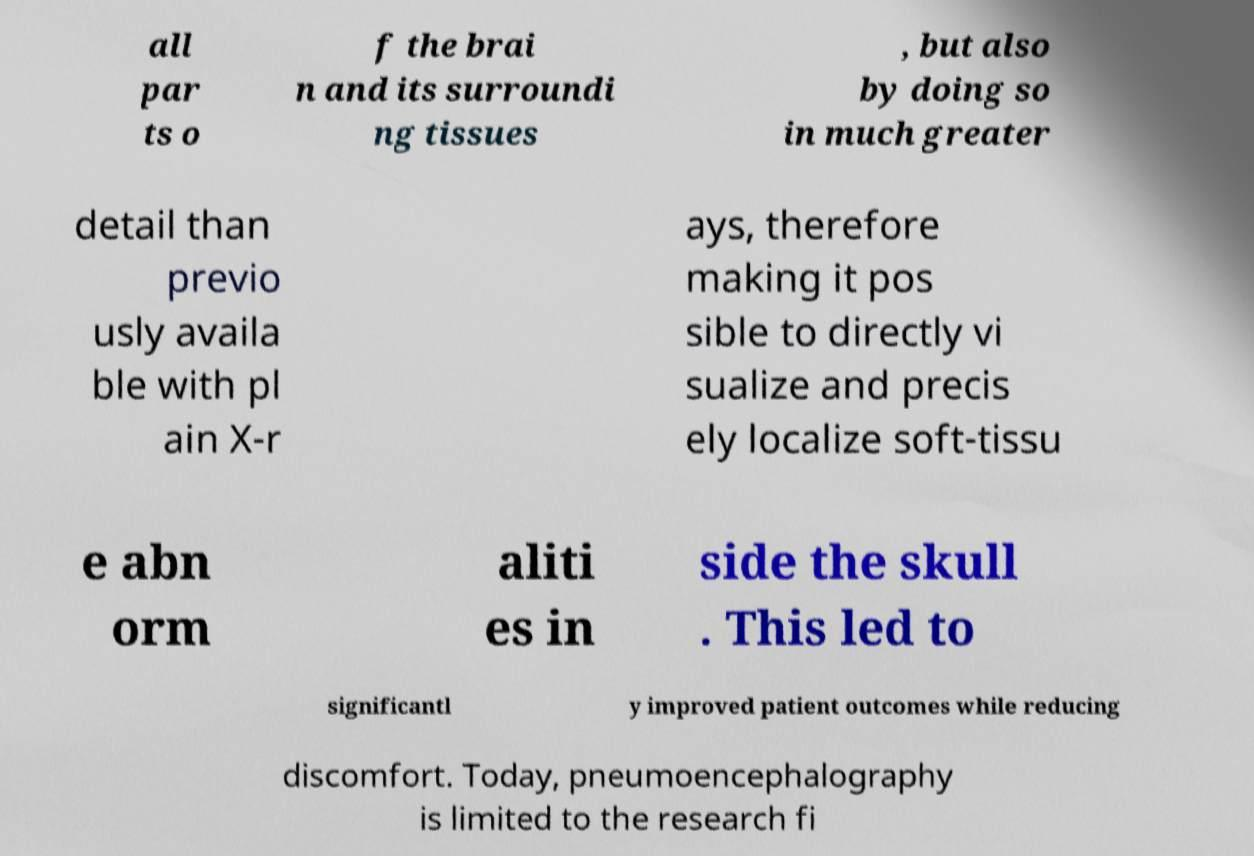Can you accurately transcribe the text from the provided image for me? all par ts o f the brai n and its surroundi ng tissues , but also by doing so in much greater detail than previo usly availa ble with pl ain X-r ays, therefore making it pos sible to directly vi sualize and precis ely localize soft-tissu e abn orm aliti es in side the skull . This led to significantl y improved patient outcomes while reducing discomfort. Today, pneumoencephalography is limited to the research fi 